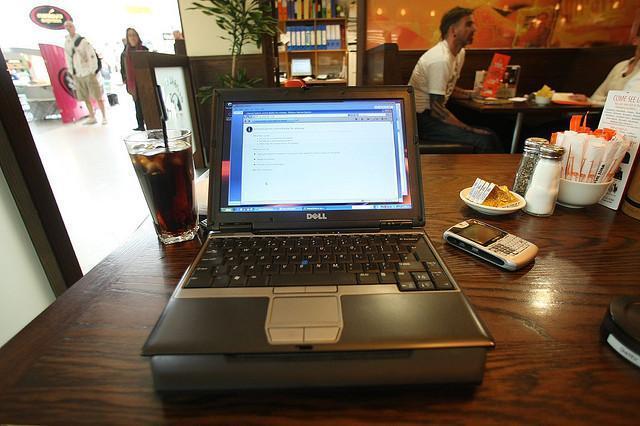How many people are there?
Give a very brief answer. 2. How many cell phones can be seen?
Give a very brief answer. 1. How many bikes have a helmet attached to the handlebar?
Give a very brief answer. 0. 